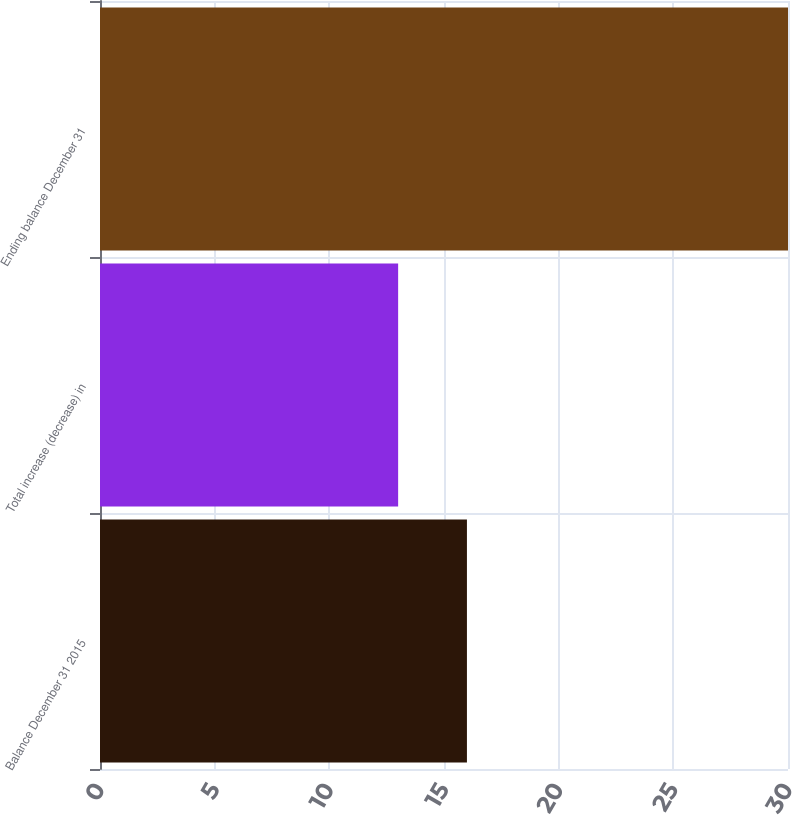<chart> <loc_0><loc_0><loc_500><loc_500><bar_chart><fcel>Balance December 31 2015<fcel>Total increase (decrease) in<fcel>Ending balance December 31<nl><fcel>16<fcel>13<fcel>30<nl></chart> 